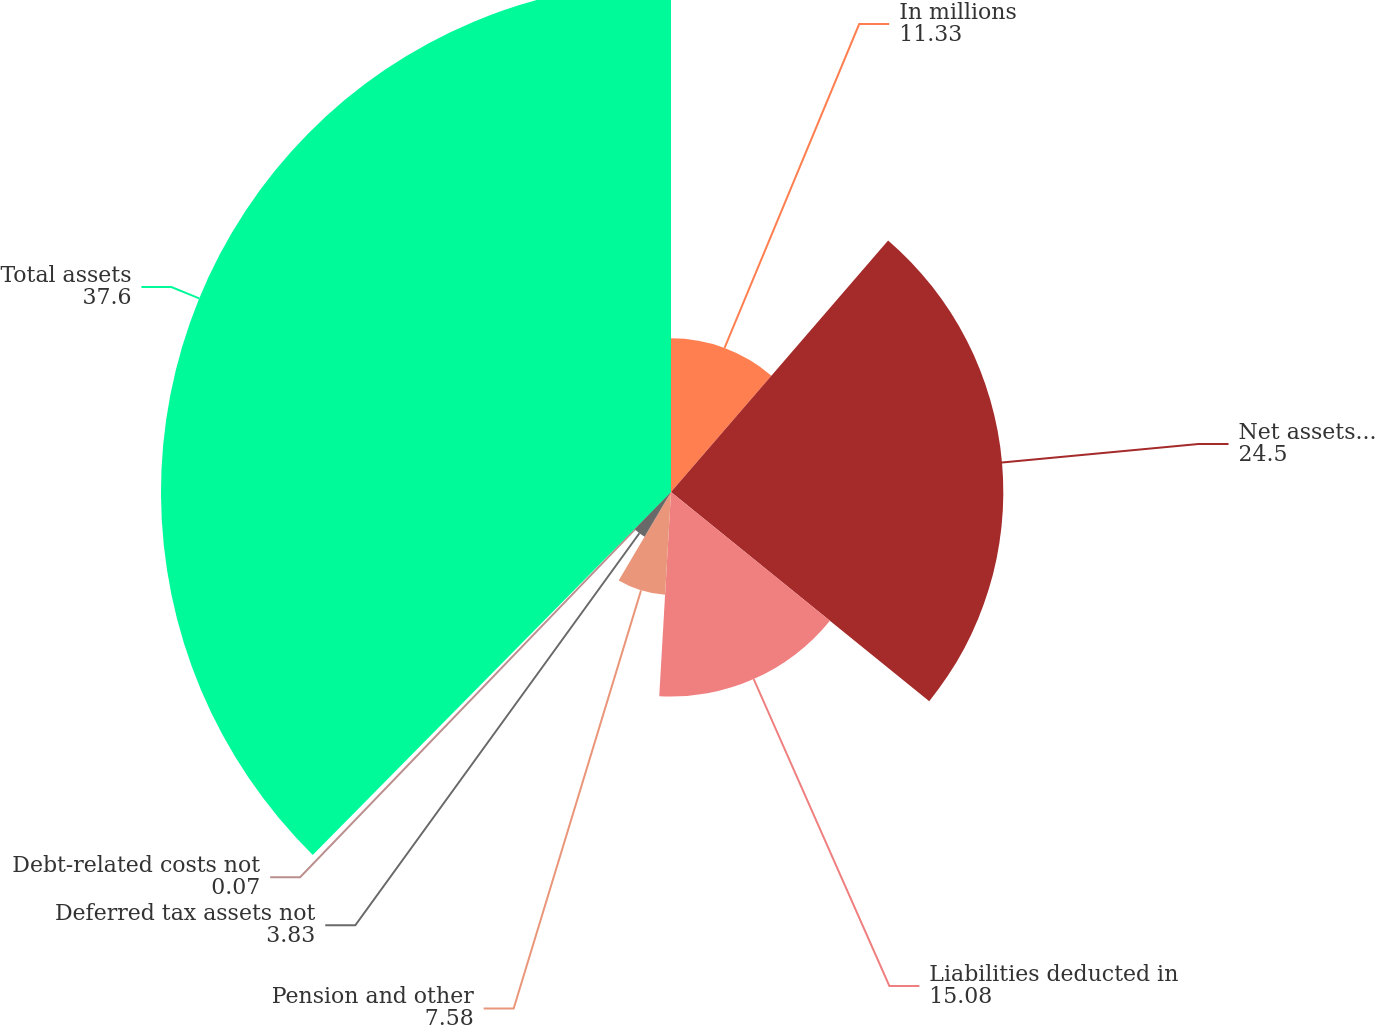Convert chart to OTSL. <chart><loc_0><loc_0><loc_500><loc_500><pie_chart><fcel>In millions<fcel>Net assets for operating<fcel>Liabilities deducted in<fcel>Pension and other<fcel>Deferred tax assets not<fcel>Debt-related costs not<fcel>Total assets<nl><fcel>11.33%<fcel>24.5%<fcel>15.08%<fcel>7.58%<fcel>3.83%<fcel>0.07%<fcel>37.6%<nl></chart> 